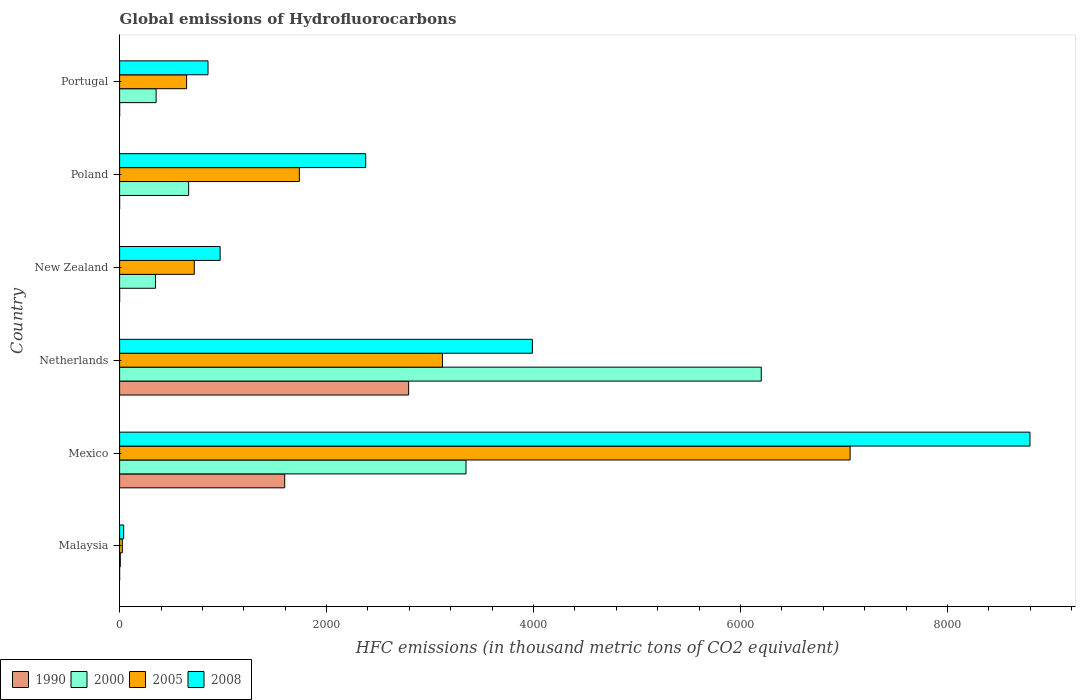How many different coloured bars are there?
Your response must be concise. 4. Are the number of bars on each tick of the Y-axis equal?
Your response must be concise. Yes. How many bars are there on the 6th tick from the top?
Ensure brevity in your answer.  4. How many bars are there on the 1st tick from the bottom?
Keep it short and to the point. 4. What is the label of the 5th group of bars from the top?
Offer a terse response. Mexico. In how many cases, is the number of bars for a given country not equal to the number of legend labels?
Offer a terse response. 0. What is the global emissions of Hydrofluorocarbons in 1990 in Mexico?
Make the answer very short. 1595.3. Across all countries, what is the maximum global emissions of Hydrofluorocarbons in 1990?
Keep it short and to the point. 2792.9. Across all countries, what is the minimum global emissions of Hydrofluorocarbons in 2005?
Provide a succinct answer. 26.1. In which country was the global emissions of Hydrofluorocarbons in 2008 maximum?
Provide a short and direct response. Mexico. In which country was the global emissions of Hydrofluorocarbons in 2005 minimum?
Provide a short and direct response. Malaysia. What is the total global emissions of Hydrofluorocarbons in 2005 in the graph?
Keep it short and to the point. 1.33e+04. What is the difference between the global emissions of Hydrofluorocarbons in 2005 in Malaysia and that in Portugal?
Ensure brevity in your answer.  -621.6. What is the difference between the global emissions of Hydrofluorocarbons in 2000 in Poland and the global emissions of Hydrofluorocarbons in 1990 in Mexico?
Your response must be concise. -928.1. What is the average global emissions of Hydrofluorocarbons in 1990 per country?
Keep it short and to the point. 731.47. What is the difference between the global emissions of Hydrofluorocarbons in 2000 and global emissions of Hydrofluorocarbons in 1990 in Malaysia?
Offer a very short reply. 6.8. What is the ratio of the global emissions of Hydrofluorocarbons in 1990 in Netherlands to that in Portugal?
Keep it short and to the point. 1.40e+04. Is the difference between the global emissions of Hydrofluorocarbons in 2000 in Malaysia and Mexico greater than the difference between the global emissions of Hydrofluorocarbons in 1990 in Malaysia and Mexico?
Make the answer very short. No. What is the difference between the highest and the second highest global emissions of Hydrofluorocarbons in 2000?
Your response must be concise. 2853.1. What is the difference between the highest and the lowest global emissions of Hydrofluorocarbons in 2008?
Make the answer very short. 8757.7. Is it the case that in every country, the sum of the global emissions of Hydrofluorocarbons in 2008 and global emissions of Hydrofluorocarbons in 2005 is greater than the sum of global emissions of Hydrofluorocarbons in 2000 and global emissions of Hydrofluorocarbons in 1990?
Offer a terse response. No. What does the 4th bar from the top in Netherlands represents?
Offer a terse response. 1990. Is it the case that in every country, the sum of the global emissions of Hydrofluorocarbons in 2008 and global emissions of Hydrofluorocarbons in 2000 is greater than the global emissions of Hydrofluorocarbons in 2005?
Give a very brief answer. Yes. Are the values on the major ticks of X-axis written in scientific E-notation?
Ensure brevity in your answer.  No. Does the graph contain any zero values?
Give a very brief answer. No. Does the graph contain grids?
Offer a very short reply. No. Where does the legend appear in the graph?
Give a very brief answer. Bottom left. How many legend labels are there?
Keep it short and to the point. 4. How are the legend labels stacked?
Provide a short and direct response. Horizontal. What is the title of the graph?
Provide a short and direct response. Global emissions of Hydrofluorocarbons. What is the label or title of the X-axis?
Make the answer very short. HFC emissions (in thousand metric tons of CO2 equivalent). What is the HFC emissions (in thousand metric tons of CO2 equivalent) of 1990 in Malaysia?
Your answer should be very brief. 0.1. What is the HFC emissions (in thousand metric tons of CO2 equivalent) in 2000 in Malaysia?
Make the answer very short. 6.9. What is the HFC emissions (in thousand metric tons of CO2 equivalent) in 2005 in Malaysia?
Your response must be concise. 26.1. What is the HFC emissions (in thousand metric tons of CO2 equivalent) of 2008 in Malaysia?
Your response must be concise. 39.2. What is the HFC emissions (in thousand metric tons of CO2 equivalent) in 1990 in Mexico?
Make the answer very short. 1595.3. What is the HFC emissions (in thousand metric tons of CO2 equivalent) of 2000 in Mexico?
Keep it short and to the point. 3347.3. What is the HFC emissions (in thousand metric tons of CO2 equivalent) in 2005 in Mexico?
Provide a short and direct response. 7058.9. What is the HFC emissions (in thousand metric tons of CO2 equivalent) in 2008 in Mexico?
Give a very brief answer. 8796.9. What is the HFC emissions (in thousand metric tons of CO2 equivalent) of 1990 in Netherlands?
Your answer should be compact. 2792.9. What is the HFC emissions (in thousand metric tons of CO2 equivalent) of 2000 in Netherlands?
Your answer should be very brief. 6200.4. What is the HFC emissions (in thousand metric tons of CO2 equivalent) of 2005 in Netherlands?
Your answer should be very brief. 3119.5. What is the HFC emissions (in thousand metric tons of CO2 equivalent) in 2008 in Netherlands?
Provide a short and direct response. 3988.8. What is the HFC emissions (in thousand metric tons of CO2 equivalent) in 1990 in New Zealand?
Make the answer very short. 0.2. What is the HFC emissions (in thousand metric tons of CO2 equivalent) in 2000 in New Zealand?
Ensure brevity in your answer.  347.3. What is the HFC emissions (in thousand metric tons of CO2 equivalent) in 2005 in New Zealand?
Make the answer very short. 721.7. What is the HFC emissions (in thousand metric tons of CO2 equivalent) of 2008 in New Zealand?
Keep it short and to the point. 971.4. What is the HFC emissions (in thousand metric tons of CO2 equivalent) of 2000 in Poland?
Provide a short and direct response. 667.2. What is the HFC emissions (in thousand metric tons of CO2 equivalent) in 2005 in Poland?
Give a very brief answer. 1736.7. What is the HFC emissions (in thousand metric tons of CO2 equivalent) of 2008 in Poland?
Your response must be concise. 2378. What is the HFC emissions (in thousand metric tons of CO2 equivalent) in 2000 in Portugal?
Provide a succinct answer. 352.7. What is the HFC emissions (in thousand metric tons of CO2 equivalent) in 2005 in Portugal?
Your answer should be compact. 647.7. What is the HFC emissions (in thousand metric tons of CO2 equivalent) of 2008 in Portugal?
Offer a terse response. 854.4. Across all countries, what is the maximum HFC emissions (in thousand metric tons of CO2 equivalent) in 1990?
Give a very brief answer. 2792.9. Across all countries, what is the maximum HFC emissions (in thousand metric tons of CO2 equivalent) of 2000?
Offer a terse response. 6200.4. Across all countries, what is the maximum HFC emissions (in thousand metric tons of CO2 equivalent) in 2005?
Offer a very short reply. 7058.9. Across all countries, what is the maximum HFC emissions (in thousand metric tons of CO2 equivalent) of 2008?
Give a very brief answer. 8796.9. Across all countries, what is the minimum HFC emissions (in thousand metric tons of CO2 equivalent) in 1990?
Offer a very short reply. 0.1. Across all countries, what is the minimum HFC emissions (in thousand metric tons of CO2 equivalent) of 2005?
Keep it short and to the point. 26.1. Across all countries, what is the minimum HFC emissions (in thousand metric tons of CO2 equivalent) in 2008?
Provide a succinct answer. 39.2. What is the total HFC emissions (in thousand metric tons of CO2 equivalent) in 1990 in the graph?
Offer a terse response. 4388.8. What is the total HFC emissions (in thousand metric tons of CO2 equivalent) in 2000 in the graph?
Ensure brevity in your answer.  1.09e+04. What is the total HFC emissions (in thousand metric tons of CO2 equivalent) in 2005 in the graph?
Offer a very short reply. 1.33e+04. What is the total HFC emissions (in thousand metric tons of CO2 equivalent) of 2008 in the graph?
Offer a very short reply. 1.70e+04. What is the difference between the HFC emissions (in thousand metric tons of CO2 equivalent) of 1990 in Malaysia and that in Mexico?
Your answer should be very brief. -1595.2. What is the difference between the HFC emissions (in thousand metric tons of CO2 equivalent) in 2000 in Malaysia and that in Mexico?
Ensure brevity in your answer.  -3340.4. What is the difference between the HFC emissions (in thousand metric tons of CO2 equivalent) of 2005 in Malaysia and that in Mexico?
Give a very brief answer. -7032.8. What is the difference between the HFC emissions (in thousand metric tons of CO2 equivalent) in 2008 in Malaysia and that in Mexico?
Provide a succinct answer. -8757.7. What is the difference between the HFC emissions (in thousand metric tons of CO2 equivalent) in 1990 in Malaysia and that in Netherlands?
Provide a short and direct response. -2792.8. What is the difference between the HFC emissions (in thousand metric tons of CO2 equivalent) of 2000 in Malaysia and that in Netherlands?
Your response must be concise. -6193.5. What is the difference between the HFC emissions (in thousand metric tons of CO2 equivalent) in 2005 in Malaysia and that in Netherlands?
Offer a terse response. -3093.4. What is the difference between the HFC emissions (in thousand metric tons of CO2 equivalent) in 2008 in Malaysia and that in Netherlands?
Give a very brief answer. -3949.6. What is the difference between the HFC emissions (in thousand metric tons of CO2 equivalent) of 2000 in Malaysia and that in New Zealand?
Ensure brevity in your answer.  -340.4. What is the difference between the HFC emissions (in thousand metric tons of CO2 equivalent) of 2005 in Malaysia and that in New Zealand?
Offer a terse response. -695.6. What is the difference between the HFC emissions (in thousand metric tons of CO2 equivalent) of 2008 in Malaysia and that in New Zealand?
Offer a terse response. -932.2. What is the difference between the HFC emissions (in thousand metric tons of CO2 equivalent) of 1990 in Malaysia and that in Poland?
Provide a succinct answer. 0. What is the difference between the HFC emissions (in thousand metric tons of CO2 equivalent) of 2000 in Malaysia and that in Poland?
Your answer should be compact. -660.3. What is the difference between the HFC emissions (in thousand metric tons of CO2 equivalent) in 2005 in Malaysia and that in Poland?
Make the answer very short. -1710.6. What is the difference between the HFC emissions (in thousand metric tons of CO2 equivalent) of 2008 in Malaysia and that in Poland?
Provide a succinct answer. -2338.8. What is the difference between the HFC emissions (in thousand metric tons of CO2 equivalent) in 1990 in Malaysia and that in Portugal?
Offer a very short reply. -0.1. What is the difference between the HFC emissions (in thousand metric tons of CO2 equivalent) of 2000 in Malaysia and that in Portugal?
Your answer should be very brief. -345.8. What is the difference between the HFC emissions (in thousand metric tons of CO2 equivalent) in 2005 in Malaysia and that in Portugal?
Offer a very short reply. -621.6. What is the difference between the HFC emissions (in thousand metric tons of CO2 equivalent) in 2008 in Malaysia and that in Portugal?
Your answer should be compact. -815.2. What is the difference between the HFC emissions (in thousand metric tons of CO2 equivalent) of 1990 in Mexico and that in Netherlands?
Your response must be concise. -1197.6. What is the difference between the HFC emissions (in thousand metric tons of CO2 equivalent) of 2000 in Mexico and that in Netherlands?
Make the answer very short. -2853.1. What is the difference between the HFC emissions (in thousand metric tons of CO2 equivalent) of 2005 in Mexico and that in Netherlands?
Give a very brief answer. 3939.4. What is the difference between the HFC emissions (in thousand metric tons of CO2 equivalent) in 2008 in Mexico and that in Netherlands?
Your answer should be compact. 4808.1. What is the difference between the HFC emissions (in thousand metric tons of CO2 equivalent) in 1990 in Mexico and that in New Zealand?
Keep it short and to the point. 1595.1. What is the difference between the HFC emissions (in thousand metric tons of CO2 equivalent) of 2000 in Mexico and that in New Zealand?
Offer a very short reply. 3000. What is the difference between the HFC emissions (in thousand metric tons of CO2 equivalent) of 2005 in Mexico and that in New Zealand?
Your answer should be very brief. 6337.2. What is the difference between the HFC emissions (in thousand metric tons of CO2 equivalent) in 2008 in Mexico and that in New Zealand?
Provide a short and direct response. 7825.5. What is the difference between the HFC emissions (in thousand metric tons of CO2 equivalent) of 1990 in Mexico and that in Poland?
Your answer should be compact. 1595.2. What is the difference between the HFC emissions (in thousand metric tons of CO2 equivalent) in 2000 in Mexico and that in Poland?
Your answer should be very brief. 2680.1. What is the difference between the HFC emissions (in thousand metric tons of CO2 equivalent) of 2005 in Mexico and that in Poland?
Make the answer very short. 5322.2. What is the difference between the HFC emissions (in thousand metric tons of CO2 equivalent) in 2008 in Mexico and that in Poland?
Provide a succinct answer. 6418.9. What is the difference between the HFC emissions (in thousand metric tons of CO2 equivalent) of 1990 in Mexico and that in Portugal?
Provide a succinct answer. 1595.1. What is the difference between the HFC emissions (in thousand metric tons of CO2 equivalent) in 2000 in Mexico and that in Portugal?
Give a very brief answer. 2994.6. What is the difference between the HFC emissions (in thousand metric tons of CO2 equivalent) of 2005 in Mexico and that in Portugal?
Give a very brief answer. 6411.2. What is the difference between the HFC emissions (in thousand metric tons of CO2 equivalent) of 2008 in Mexico and that in Portugal?
Offer a very short reply. 7942.5. What is the difference between the HFC emissions (in thousand metric tons of CO2 equivalent) in 1990 in Netherlands and that in New Zealand?
Your answer should be compact. 2792.7. What is the difference between the HFC emissions (in thousand metric tons of CO2 equivalent) of 2000 in Netherlands and that in New Zealand?
Your answer should be very brief. 5853.1. What is the difference between the HFC emissions (in thousand metric tons of CO2 equivalent) in 2005 in Netherlands and that in New Zealand?
Ensure brevity in your answer.  2397.8. What is the difference between the HFC emissions (in thousand metric tons of CO2 equivalent) of 2008 in Netherlands and that in New Zealand?
Keep it short and to the point. 3017.4. What is the difference between the HFC emissions (in thousand metric tons of CO2 equivalent) in 1990 in Netherlands and that in Poland?
Keep it short and to the point. 2792.8. What is the difference between the HFC emissions (in thousand metric tons of CO2 equivalent) of 2000 in Netherlands and that in Poland?
Provide a succinct answer. 5533.2. What is the difference between the HFC emissions (in thousand metric tons of CO2 equivalent) in 2005 in Netherlands and that in Poland?
Your response must be concise. 1382.8. What is the difference between the HFC emissions (in thousand metric tons of CO2 equivalent) of 2008 in Netherlands and that in Poland?
Provide a succinct answer. 1610.8. What is the difference between the HFC emissions (in thousand metric tons of CO2 equivalent) in 1990 in Netherlands and that in Portugal?
Your response must be concise. 2792.7. What is the difference between the HFC emissions (in thousand metric tons of CO2 equivalent) of 2000 in Netherlands and that in Portugal?
Provide a succinct answer. 5847.7. What is the difference between the HFC emissions (in thousand metric tons of CO2 equivalent) in 2005 in Netherlands and that in Portugal?
Ensure brevity in your answer.  2471.8. What is the difference between the HFC emissions (in thousand metric tons of CO2 equivalent) in 2008 in Netherlands and that in Portugal?
Keep it short and to the point. 3134.4. What is the difference between the HFC emissions (in thousand metric tons of CO2 equivalent) of 2000 in New Zealand and that in Poland?
Provide a short and direct response. -319.9. What is the difference between the HFC emissions (in thousand metric tons of CO2 equivalent) of 2005 in New Zealand and that in Poland?
Make the answer very short. -1015. What is the difference between the HFC emissions (in thousand metric tons of CO2 equivalent) in 2008 in New Zealand and that in Poland?
Provide a succinct answer. -1406.6. What is the difference between the HFC emissions (in thousand metric tons of CO2 equivalent) in 2000 in New Zealand and that in Portugal?
Make the answer very short. -5.4. What is the difference between the HFC emissions (in thousand metric tons of CO2 equivalent) in 2005 in New Zealand and that in Portugal?
Offer a terse response. 74. What is the difference between the HFC emissions (in thousand metric tons of CO2 equivalent) in 2008 in New Zealand and that in Portugal?
Ensure brevity in your answer.  117. What is the difference between the HFC emissions (in thousand metric tons of CO2 equivalent) of 2000 in Poland and that in Portugal?
Keep it short and to the point. 314.5. What is the difference between the HFC emissions (in thousand metric tons of CO2 equivalent) of 2005 in Poland and that in Portugal?
Ensure brevity in your answer.  1089. What is the difference between the HFC emissions (in thousand metric tons of CO2 equivalent) in 2008 in Poland and that in Portugal?
Your answer should be compact. 1523.6. What is the difference between the HFC emissions (in thousand metric tons of CO2 equivalent) of 1990 in Malaysia and the HFC emissions (in thousand metric tons of CO2 equivalent) of 2000 in Mexico?
Provide a short and direct response. -3347.2. What is the difference between the HFC emissions (in thousand metric tons of CO2 equivalent) of 1990 in Malaysia and the HFC emissions (in thousand metric tons of CO2 equivalent) of 2005 in Mexico?
Offer a terse response. -7058.8. What is the difference between the HFC emissions (in thousand metric tons of CO2 equivalent) of 1990 in Malaysia and the HFC emissions (in thousand metric tons of CO2 equivalent) of 2008 in Mexico?
Keep it short and to the point. -8796.8. What is the difference between the HFC emissions (in thousand metric tons of CO2 equivalent) of 2000 in Malaysia and the HFC emissions (in thousand metric tons of CO2 equivalent) of 2005 in Mexico?
Offer a very short reply. -7052. What is the difference between the HFC emissions (in thousand metric tons of CO2 equivalent) in 2000 in Malaysia and the HFC emissions (in thousand metric tons of CO2 equivalent) in 2008 in Mexico?
Your response must be concise. -8790. What is the difference between the HFC emissions (in thousand metric tons of CO2 equivalent) in 2005 in Malaysia and the HFC emissions (in thousand metric tons of CO2 equivalent) in 2008 in Mexico?
Offer a very short reply. -8770.8. What is the difference between the HFC emissions (in thousand metric tons of CO2 equivalent) of 1990 in Malaysia and the HFC emissions (in thousand metric tons of CO2 equivalent) of 2000 in Netherlands?
Provide a succinct answer. -6200.3. What is the difference between the HFC emissions (in thousand metric tons of CO2 equivalent) of 1990 in Malaysia and the HFC emissions (in thousand metric tons of CO2 equivalent) of 2005 in Netherlands?
Your response must be concise. -3119.4. What is the difference between the HFC emissions (in thousand metric tons of CO2 equivalent) in 1990 in Malaysia and the HFC emissions (in thousand metric tons of CO2 equivalent) in 2008 in Netherlands?
Provide a succinct answer. -3988.7. What is the difference between the HFC emissions (in thousand metric tons of CO2 equivalent) of 2000 in Malaysia and the HFC emissions (in thousand metric tons of CO2 equivalent) of 2005 in Netherlands?
Offer a terse response. -3112.6. What is the difference between the HFC emissions (in thousand metric tons of CO2 equivalent) in 2000 in Malaysia and the HFC emissions (in thousand metric tons of CO2 equivalent) in 2008 in Netherlands?
Give a very brief answer. -3981.9. What is the difference between the HFC emissions (in thousand metric tons of CO2 equivalent) of 2005 in Malaysia and the HFC emissions (in thousand metric tons of CO2 equivalent) of 2008 in Netherlands?
Offer a terse response. -3962.7. What is the difference between the HFC emissions (in thousand metric tons of CO2 equivalent) of 1990 in Malaysia and the HFC emissions (in thousand metric tons of CO2 equivalent) of 2000 in New Zealand?
Offer a very short reply. -347.2. What is the difference between the HFC emissions (in thousand metric tons of CO2 equivalent) of 1990 in Malaysia and the HFC emissions (in thousand metric tons of CO2 equivalent) of 2005 in New Zealand?
Provide a succinct answer. -721.6. What is the difference between the HFC emissions (in thousand metric tons of CO2 equivalent) in 1990 in Malaysia and the HFC emissions (in thousand metric tons of CO2 equivalent) in 2008 in New Zealand?
Provide a succinct answer. -971.3. What is the difference between the HFC emissions (in thousand metric tons of CO2 equivalent) of 2000 in Malaysia and the HFC emissions (in thousand metric tons of CO2 equivalent) of 2005 in New Zealand?
Your answer should be very brief. -714.8. What is the difference between the HFC emissions (in thousand metric tons of CO2 equivalent) of 2000 in Malaysia and the HFC emissions (in thousand metric tons of CO2 equivalent) of 2008 in New Zealand?
Provide a short and direct response. -964.5. What is the difference between the HFC emissions (in thousand metric tons of CO2 equivalent) of 2005 in Malaysia and the HFC emissions (in thousand metric tons of CO2 equivalent) of 2008 in New Zealand?
Make the answer very short. -945.3. What is the difference between the HFC emissions (in thousand metric tons of CO2 equivalent) of 1990 in Malaysia and the HFC emissions (in thousand metric tons of CO2 equivalent) of 2000 in Poland?
Ensure brevity in your answer.  -667.1. What is the difference between the HFC emissions (in thousand metric tons of CO2 equivalent) in 1990 in Malaysia and the HFC emissions (in thousand metric tons of CO2 equivalent) in 2005 in Poland?
Provide a short and direct response. -1736.6. What is the difference between the HFC emissions (in thousand metric tons of CO2 equivalent) of 1990 in Malaysia and the HFC emissions (in thousand metric tons of CO2 equivalent) of 2008 in Poland?
Provide a succinct answer. -2377.9. What is the difference between the HFC emissions (in thousand metric tons of CO2 equivalent) of 2000 in Malaysia and the HFC emissions (in thousand metric tons of CO2 equivalent) of 2005 in Poland?
Your answer should be very brief. -1729.8. What is the difference between the HFC emissions (in thousand metric tons of CO2 equivalent) in 2000 in Malaysia and the HFC emissions (in thousand metric tons of CO2 equivalent) in 2008 in Poland?
Give a very brief answer. -2371.1. What is the difference between the HFC emissions (in thousand metric tons of CO2 equivalent) of 2005 in Malaysia and the HFC emissions (in thousand metric tons of CO2 equivalent) of 2008 in Poland?
Offer a very short reply. -2351.9. What is the difference between the HFC emissions (in thousand metric tons of CO2 equivalent) in 1990 in Malaysia and the HFC emissions (in thousand metric tons of CO2 equivalent) in 2000 in Portugal?
Provide a succinct answer. -352.6. What is the difference between the HFC emissions (in thousand metric tons of CO2 equivalent) of 1990 in Malaysia and the HFC emissions (in thousand metric tons of CO2 equivalent) of 2005 in Portugal?
Offer a terse response. -647.6. What is the difference between the HFC emissions (in thousand metric tons of CO2 equivalent) in 1990 in Malaysia and the HFC emissions (in thousand metric tons of CO2 equivalent) in 2008 in Portugal?
Your answer should be compact. -854.3. What is the difference between the HFC emissions (in thousand metric tons of CO2 equivalent) in 2000 in Malaysia and the HFC emissions (in thousand metric tons of CO2 equivalent) in 2005 in Portugal?
Give a very brief answer. -640.8. What is the difference between the HFC emissions (in thousand metric tons of CO2 equivalent) in 2000 in Malaysia and the HFC emissions (in thousand metric tons of CO2 equivalent) in 2008 in Portugal?
Make the answer very short. -847.5. What is the difference between the HFC emissions (in thousand metric tons of CO2 equivalent) of 2005 in Malaysia and the HFC emissions (in thousand metric tons of CO2 equivalent) of 2008 in Portugal?
Your response must be concise. -828.3. What is the difference between the HFC emissions (in thousand metric tons of CO2 equivalent) in 1990 in Mexico and the HFC emissions (in thousand metric tons of CO2 equivalent) in 2000 in Netherlands?
Keep it short and to the point. -4605.1. What is the difference between the HFC emissions (in thousand metric tons of CO2 equivalent) of 1990 in Mexico and the HFC emissions (in thousand metric tons of CO2 equivalent) of 2005 in Netherlands?
Give a very brief answer. -1524.2. What is the difference between the HFC emissions (in thousand metric tons of CO2 equivalent) in 1990 in Mexico and the HFC emissions (in thousand metric tons of CO2 equivalent) in 2008 in Netherlands?
Ensure brevity in your answer.  -2393.5. What is the difference between the HFC emissions (in thousand metric tons of CO2 equivalent) in 2000 in Mexico and the HFC emissions (in thousand metric tons of CO2 equivalent) in 2005 in Netherlands?
Keep it short and to the point. 227.8. What is the difference between the HFC emissions (in thousand metric tons of CO2 equivalent) in 2000 in Mexico and the HFC emissions (in thousand metric tons of CO2 equivalent) in 2008 in Netherlands?
Provide a succinct answer. -641.5. What is the difference between the HFC emissions (in thousand metric tons of CO2 equivalent) in 2005 in Mexico and the HFC emissions (in thousand metric tons of CO2 equivalent) in 2008 in Netherlands?
Provide a succinct answer. 3070.1. What is the difference between the HFC emissions (in thousand metric tons of CO2 equivalent) in 1990 in Mexico and the HFC emissions (in thousand metric tons of CO2 equivalent) in 2000 in New Zealand?
Your answer should be very brief. 1248. What is the difference between the HFC emissions (in thousand metric tons of CO2 equivalent) in 1990 in Mexico and the HFC emissions (in thousand metric tons of CO2 equivalent) in 2005 in New Zealand?
Ensure brevity in your answer.  873.6. What is the difference between the HFC emissions (in thousand metric tons of CO2 equivalent) in 1990 in Mexico and the HFC emissions (in thousand metric tons of CO2 equivalent) in 2008 in New Zealand?
Offer a very short reply. 623.9. What is the difference between the HFC emissions (in thousand metric tons of CO2 equivalent) in 2000 in Mexico and the HFC emissions (in thousand metric tons of CO2 equivalent) in 2005 in New Zealand?
Offer a very short reply. 2625.6. What is the difference between the HFC emissions (in thousand metric tons of CO2 equivalent) of 2000 in Mexico and the HFC emissions (in thousand metric tons of CO2 equivalent) of 2008 in New Zealand?
Your response must be concise. 2375.9. What is the difference between the HFC emissions (in thousand metric tons of CO2 equivalent) of 2005 in Mexico and the HFC emissions (in thousand metric tons of CO2 equivalent) of 2008 in New Zealand?
Your answer should be very brief. 6087.5. What is the difference between the HFC emissions (in thousand metric tons of CO2 equivalent) of 1990 in Mexico and the HFC emissions (in thousand metric tons of CO2 equivalent) of 2000 in Poland?
Ensure brevity in your answer.  928.1. What is the difference between the HFC emissions (in thousand metric tons of CO2 equivalent) of 1990 in Mexico and the HFC emissions (in thousand metric tons of CO2 equivalent) of 2005 in Poland?
Your answer should be compact. -141.4. What is the difference between the HFC emissions (in thousand metric tons of CO2 equivalent) in 1990 in Mexico and the HFC emissions (in thousand metric tons of CO2 equivalent) in 2008 in Poland?
Your response must be concise. -782.7. What is the difference between the HFC emissions (in thousand metric tons of CO2 equivalent) of 2000 in Mexico and the HFC emissions (in thousand metric tons of CO2 equivalent) of 2005 in Poland?
Offer a terse response. 1610.6. What is the difference between the HFC emissions (in thousand metric tons of CO2 equivalent) of 2000 in Mexico and the HFC emissions (in thousand metric tons of CO2 equivalent) of 2008 in Poland?
Make the answer very short. 969.3. What is the difference between the HFC emissions (in thousand metric tons of CO2 equivalent) in 2005 in Mexico and the HFC emissions (in thousand metric tons of CO2 equivalent) in 2008 in Poland?
Your answer should be compact. 4680.9. What is the difference between the HFC emissions (in thousand metric tons of CO2 equivalent) in 1990 in Mexico and the HFC emissions (in thousand metric tons of CO2 equivalent) in 2000 in Portugal?
Your answer should be very brief. 1242.6. What is the difference between the HFC emissions (in thousand metric tons of CO2 equivalent) in 1990 in Mexico and the HFC emissions (in thousand metric tons of CO2 equivalent) in 2005 in Portugal?
Provide a short and direct response. 947.6. What is the difference between the HFC emissions (in thousand metric tons of CO2 equivalent) of 1990 in Mexico and the HFC emissions (in thousand metric tons of CO2 equivalent) of 2008 in Portugal?
Make the answer very short. 740.9. What is the difference between the HFC emissions (in thousand metric tons of CO2 equivalent) in 2000 in Mexico and the HFC emissions (in thousand metric tons of CO2 equivalent) in 2005 in Portugal?
Provide a short and direct response. 2699.6. What is the difference between the HFC emissions (in thousand metric tons of CO2 equivalent) of 2000 in Mexico and the HFC emissions (in thousand metric tons of CO2 equivalent) of 2008 in Portugal?
Ensure brevity in your answer.  2492.9. What is the difference between the HFC emissions (in thousand metric tons of CO2 equivalent) of 2005 in Mexico and the HFC emissions (in thousand metric tons of CO2 equivalent) of 2008 in Portugal?
Offer a terse response. 6204.5. What is the difference between the HFC emissions (in thousand metric tons of CO2 equivalent) in 1990 in Netherlands and the HFC emissions (in thousand metric tons of CO2 equivalent) in 2000 in New Zealand?
Your response must be concise. 2445.6. What is the difference between the HFC emissions (in thousand metric tons of CO2 equivalent) in 1990 in Netherlands and the HFC emissions (in thousand metric tons of CO2 equivalent) in 2005 in New Zealand?
Your answer should be very brief. 2071.2. What is the difference between the HFC emissions (in thousand metric tons of CO2 equivalent) in 1990 in Netherlands and the HFC emissions (in thousand metric tons of CO2 equivalent) in 2008 in New Zealand?
Your response must be concise. 1821.5. What is the difference between the HFC emissions (in thousand metric tons of CO2 equivalent) of 2000 in Netherlands and the HFC emissions (in thousand metric tons of CO2 equivalent) of 2005 in New Zealand?
Your answer should be very brief. 5478.7. What is the difference between the HFC emissions (in thousand metric tons of CO2 equivalent) in 2000 in Netherlands and the HFC emissions (in thousand metric tons of CO2 equivalent) in 2008 in New Zealand?
Offer a terse response. 5229. What is the difference between the HFC emissions (in thousand metric tons of CO2 equivalent) of 2005 in Netherlands and the HFC emissions (in thousand metric tons of CO2 equivalent) of 2008 in New Zealand?
Your answer should be compact. 2148.1. What is the difference between the HFC emissions (in thousand metric tons of CO2 equivalent) in 1990 in Netherlands and the HFC emissions (in thousand metric tons of CO2 equivalent) in 2000 in Poland?
Keep it short and to the point. 2125.7. What is the difference between the HFC emissions (in thousand metric tons of CO2 equivalent) in 1990 in Netherlands and the HFC emissions (in thousand metric tons of CO2 equivalent) in 2005 in Poland?
Give a very brief answer. 1056.2. What is the difference between the HFC emissions (in thousand metric tons of CO2 equivalent) in 1990 in Netherlands and the HFC emissions (in thousand metric tons of CO2 equivalent) in 2008 in Poland?
Your answer should be very brief. 414.9. What is the difference between the HFC emissions (in thousand metric tons of CO2 equivalent) of 2000 in Netherlands and the HFC emissions (in thousand metric tons of CO2 equivalent) of 2005 in Poland?
Keep it short and to the point. 4463.7. What is the difference between the HFC emissions (in thousand metric tons of CO2 equivalent) in 2000 in Netherlands and the HFC emissions (in thousand metric tons of CO2 equivalent) in 2008 in Poland?
Offer a very short reply. 3822.4. What is the difference between the HFC emissions (in thousand metric tons of CO2 equivalent) of 2005 in Netherlands and the HFC emissions (in thousand metric tons of CO2 equivalent) of 2008 in Poland?
Offer a terse response. 741.5. What is the difference between the HFC emissions (in thousand metric tons of CO2 equivalent) in 1990 in Netherlands and the HFC emissions (in thousand metric tons of CO2 equivalent) in 2000 in Portugal?
Offer a very short reply. 2440.2. What is the difference between the HFC emissions (in thousand metric tons of CO2 equivalent) in 1990 in Netherlands and the HFC emissions (in thousand metric tons of CO2 equivalent) in 2005 in Portugal?
Your answer should be very brief. 2145.2. What is the difference between the HFC emissions (in thousand metric tons of CO2 equivalent) of 1990 in Netherlands and the HFC emissions (in thousand metric tons of CO2 equivalent) of 2008 in Portugal?
Provide a short and direct response. 1938.5. What is the difference between the HFC emissions (in thousand metric tons of CO2 equivalent) of 2000 in Netherlands and the HFC emissions (in thousand metric tons of CO2 equivalent) of 2005 in Portugal?
Keep it short and to the point. 5552.7. What is the difference between the HFC emissions (in thousand metric tons of CO2 equivalent) of 2000 in Netherlands and the HFC emissions (in thousand metric tons of CO2 equivalent) of 2008 in Portugal?
Offer a very short reply. 5346. What is the difference between the HFC emissions (in thousand metric tons of CO2 equivalent) of 2005 in Netherlands and the HFC emissions (in thousand metric tons of CO2 equivalent) of 2008 in Portugal?
Offer a terse response. 2265.1. What is the difference between the HFC emissions (in thousand metric tons of CO2 equivalent) in 1990 in New Zealand and the HFC emissions (in thousand metric tons of CO2 equivalent) in 2000 in Poland?
Your answer should be very brief. -667. What is the difference between the HFC emissions (in thousand metric tons of CO2 equivalent) of 1990 in New Zealand and the HFC emissions (in thousand metric tons of CO2 equivalent) of 2005 in Poland?
Give a very brief answer. -1736.5. What is the difference between the HFC emissions (in thousand metric tons of CO2 equivalent) of 1990 in New Zealand and the HFC emissions (in thousand metric tons of CO2 equivalent) of 2008 in Poland?
Provide a succinct answer. -2377.8. What is the difference between the HFC emissions (in thousand metric tons of CO2 equivalent) of 2000 in New Zealand and the HFC emissions (in thousand metric tons of CO2 equivalent) of 2005 in Poland?
Keep it short and to the point. -1389.4. What is the difference between the HFC emissions (in thousand metric tons of CO2 equivalent) of 2000 in New Zealand and the HFC emissions (in thousand metric tons of CO2 equivalent) of 2008 in Poland?
Ensure brevity in your answer.  -2030.7. What is the difference between the HFC emissions (in thousand metric tons of CO2 equivalent) in 2005 in New Zealand and the HFC emissions (in thousand metric tons of CO2 equivalent) in 2008 in Poland?
Offer a very short reply. -1656.3. What is the difference between the HFC emissions (in thousand metric tons of CO2 equivalent) of 1990 in New Zealand and the HFC emissions (in thousand metric tons of CO2 equivalent) of 2000 in Portugal?
Your answer should be very brief. -352.5. What is the difference between the HFC emissions (in thousand metric tons of CO2 equivalent) of 1990 in New Zealand and the HFC emissions (in thousand metric tons of CO2 equivalent) of 2005 in Portugal?
Offer a very short reply. -647.5. What is the difference between the HFC emissions (in thousand metric tons of CO2 equivalent) in 1990 in New Zealand and the HFC emissions (in thousand metric tons of CO2 equivalent) in 2008 in Portugal?
Keep it short and to the point. -854.2. What is the difference between the HFC emissions (in thousand metric tons of CO2 equivalent) in 2000 in New Zealand and the HFC emissions (in thousand metric tons of CO2 equivalent) in 2005 in Portugal?
Give a very brief answer. -300.4. What is the difference between the HFC emissions (in thousand metric tons of CO2 equivalent) in 2000 in New Zealand and the HFC emissions (in thousand metric tons of CO2 equivalent) in 2008 in Portugal?
Ensure brevity in your answer.  -507.1. What is the difference between the HFC emissions (in thousand metric tons of CO2 equivalent) in 2005 in New Zealand and the HFC emissions (in thousand metric tons of CO2 equivalent) in 2008 in Portugal?
Provide a succinct answer. -132.7. What is the difference between the HFC emissions (in thousand metric tons of CO2 equivalent) of 1990 in Poland and the HFC emissions (in thousand metric tons of CO2 equivalent) of 2000 in Portugal?
Your answer should be very brief. -352.6. What is the difference between the HFC emissions (in thousand metric tons of CO2 equivalent) in 1990 in Poland and the HFC emissions (in thousand metric tons of CO2 equivalent) in 2005 in Portugal?
Ensure brevity in your answer.  -647.6. What is the difference between the HFC emissions (in thousand metric tons of CO2 equivalent) of 1990 in Poland and the HFC emissions (in thousand metric tons of CO2 equivalent) of 2008 in Portugal?
Give a very brief answer. -854.3. What is the difference between the HFC emissions (in thousand metric tons of CO2 equivalent) in 2000 in Poland and the HFC emissions (in thousand metric tons of CO2 equivalent) in 2008 in Portugal?
Give a very brief answer. -187.2. What is the difference between the HFC emissions (in thousand metric tons of CO2 equivalent) of 2005 in Poland and the HFC emissions (in thousand metric tons of CO2 equivalent) of 2008 in Portugal?
Make the answer very short. 882.3. What is the average HFC emissions (in thousand metric tons of CO2 equivalent) in 1990 per country?
Provide a short and direct response. 731.47. What is the average HFC emissions (in thousand metric tons of CO2 equivalent) of 2000 per country?
Provide a succinct answer. 1820.3. What is the average HFC emissions (in thousand metric tons of CO2 equivalent) of 2005 per country?
Provide a short and direct response. 2218.43. What is the average HFC emissions (in thousand metric tons of CO2 equivalent) of 2008 per country?
Your answer should be compact. 2838.12. What is the difference between the HFC emissions (in thousand metric tons of CO2 equivalent) in 1990 and HFC emissions (in thousand metric tons of CO2 equivalent) in 2008 in Malaysia?
Ensure brevity in your answer.  -39.1. What is the difference between the HFC emissions (in thousand metric tons of CO2 equivalent) in 2000 and HFC emissions (in thousand metric tons of CO2 equivalent) in 2005 in Malaysia?
Offer a very short reply. -19.2. What is the difference between the HFC emissions (in thousand metric tons of CO2 equivalent) in 2000 and HFC emissions (in thousand metric tons of CO2 equivalent) in 2008 in Malaysia?
Provide a short and direct response. -32.3. What is the difference between the HFC emissions (in thousand metric tons of CO2 equivalent) in 1990 and HFC emissions (in thousand metric tons of CO2 equivalent) in 2000 in Mexico?
Provide a succinct answer. -1752. What is the difference between the HFC emissions (in thousand metric tons of CO2 equivalent) in 1990 and HFC emissions (in thousand metric tons of CO2 equivalent) in 2005 in Mexico?
Ensure brevity in your answer.  -5463.6. What is the difference between the HFC emissions (in thousand metric tons of CO2 equivalent) in 1990 and HFC emissions (in thousand metric tons of CO2 equivalent) in 2008 in Mexico?
Provide a short and direct response. -7201.6. What is the difference between the HFC emissions (in thousand metric tons of CO2 equivalent) of 2000 and HFC emissions (in thousand metric tons of CO2 equivalent) of 2005 in Mexico?
Give a very brief answer. -3711.6. What is the difference between the HFC emissions (in thousand metric tons of CO2 equivalent) in 2000 and HFC emissions (in thousand metric tons of CO2 equivalent) in 2008 in Mexico?
Your answer should be very brief. -5449.6. What is the difference between the HFC emissions (in thousand metric tons of CO2 equivalent) in 2005 and HFC emissions (in thousand metric tons of CO2 equivalent) in 2008 in Mexico?
Give a very brief answer. -1738. What is the difference between the HFC emissions (in thousand metric tons of CO2 equivalent) in 1990 and HFC emissions (in thousand metric tons of CO2 equivalent) in 2000 in Netherlands?
Offer a terse response. -3407.5. What is the difference between the HFC emissions (in thousand metric tons of CO2 equivalent) in 1990 and HFC emissions (in thousand metric tons of CO2 equivalent) in 2005 in Netherlands?
Your answer should be very brief. -326.6. What is the difference between the HFC emissions (in thousand metric tons of CO2 equivalent) of 1990 and HFC emissions (in thousand metric tons of CO2 equivalent) of 2008 in Netherlands?
Your answer should be compact. -1195.9. What is the difference between the HFC emissions (in thousand metric tons of CO2 equivalent) of 2000 and HFC emissions (in thousand metric tons of CO2 equivalent) of 2005 in Netherlands?
Offer a terse response. 3080.9. What is the difference between the HFC emissions (in thousand metric tons of CO2 equivalent) in 2000 and HFC emissions (in thousand metric tons of CO2 equivalent) in 2008 in Netherlands?
Ensure brevity in your answer.  2211.6. What is the difference between the HFC emissions (in thousand metric tons of CO2 equivalent) in 2005 and HFC emissions (in thousand metric tons of CO2 equivalent) in 2008 in Netherlands?
Provide a succinct answer. -869.3. What is the difference between the HFC emissions (in thousand metric tons of CO2 equivalent) of 1990 and HFC emissions (in thousand metric tons of CO2 equivalent) of 2000 in New Zealand?
Your response must be concise. -347.1. What is the difference between the HFC emissions (in thousand metric tons of CO2 equivalent) of 1990 and HFC emissions (in thousand metric tons of CO2 equivalent) of 2005 in New Zealand?
Provide a succinct answer. -721.5. What is the difference between the HFC emissions (in thousand metric tons of CO2 equivalent) in 1990 and HFC emissions (in thousand metric tons of CO2 equivalent) in 2008 in New Zealand?
Offer a terse response. -971.2. What is the difference between the HFC emissions (in thousand metric tons of CO2 equivalent) in 2000 and HFC emissions (in thousand metric tons of CO2 equivalent) in 2005 in New Zealand?
Make the answer very short. -374.4. What is the difference between the HFC emissions (in thousand metric tons of CO2 equivalent) in 2000 and HFC emissions (in thousand metric tons of CO2 equivalent) in 2008 in New Zealand?
Your answer should be compact. -624.1. What is the difference between the HFC emissions (in thousand metric tons of CO2 equivalent) of 2005 and HFC emissions (in thousand metric tons of CO2 equivalent) of 2008 in New Zealand?
Offer a very short reply. -249.7. What is the difference between the HFC emissions (in thousand metric tons of CO2 equivalent) of 1990 and HFC emissions (in thousand metric tons of CO2 equivalent) of 2000 in Poland?
Offer a terse response. -667.1. What is the difference between the HFC emissions (in thousand metric tons of CO2 equivalent) in 1990 and HFC emissions (in thousand metric tons of CO2 equivalent) in 2005 in Poland?
Provide a succinct answer. -1736.6. What is the difference between the HFC emissions (in thousand metric tons of CO2 equivalent) in 1990 and HFC emissions (in thousand metric tons of CO2 equivalent) in 2008 in Poland?
Your answer should be very brief. -2377.9. What is the difference between the HFC emissions (in thousand metric tons of CO2 equivalent) of 2000 and HFC emissions (in thousand metric tons of CO2 equivalent) of 2005 in Poland?
Your response must be concise. -1069.5. What is the difference between the HFC emissions (in thousand metric tons of CO2 equivalent) in 2000 and HFC emissions (in thousand metric tons of CO2 equivalent) in 2008 in Poland?
Keep it short and to the point. -1710.8. What is the difference between the HFC emissions (in thousand metric tons of CO2 equivalent) of 2005 and HFC emissions (in thousand metric tons of CO2 equivalent) of 2008 in Poland?
Keep it short and to the point. -641.3. What is the difference between the HFC emissions (in thousand metric tons of CO2 equivalent) in 1990 and HFC emissions (in thousand metric tons of CO2 equivalent) in 2000 in Portugal?
Offer a very short reply. -352.5. What is the difference between the HFC emissions (in thousand metric tons of CO2 equivalent) of 1990 and HFC emissions (in thousand metric tons of CO2 equivalent) of 2005 in Portugal?
Offer a very short reply. -647.5. What is the difference between the HFC emissions (in thousand metric tons of CO2 equivalent) of 1990 and HFC emissions (in thousand metric tons of CO2 equivalent) of 2008 in Portugal?
Give a very brief answer. -854.2. What is the difference between the HFC emissions (in thousand metric tons of CO2 equivalent) in 2000 and HFC emissions (in thousand metric tons of CO2 equivalent) in 2005 in Portugal?
Provide a short and direct response. -295. What is the difference between the HFC emissions (in thousand metric tons of CO2 equivalent) of 2000 and HFC emissions (in thousand metric tons of CO2 equivalent) of 2008 in Portugal?
Provide a succinct answer. -501.7. What is the difference between the HFC emissions (in thousand metric tons of CO2 equivalent) in 2005 and HFC emissions (in thousand metric tons of CO2 equivalent) in 2008 in Portugal?
Give a very brief answer. -206.7. What is the ratio of the HFC emissions (in thousand metric tons of CO2 equivalent) of 1990 in Malaysia to that in Mexico?
Provide a succinct answer. 0. What is the ratio of the HFC emissions (in thousand metric tons of CO2 equivalent) of 2000 in Malaysia to that in Mexico?
Offer a terse response. 0. What is the ratio of the HFC emissions (in thousand metric tons of CO2 equivalent) of 2005 in Malaysia to that in Mexico?
Ensure brevity in your answer.  0. What is the ratio of the HFC emissions (in thousand metric tons of CO2 equivalent) of 2008 in Malaysia to that in Mexico?
Provide a short and direct response. 0. What is the ratio of the HFC emissions (in thousand metric tons of CO2 equivalent) of 2000 in Malaysia to that in Netherlands?
Your response must be concise. 0. What is the ratio of the HFC emissions (in thousand metric tons of CO2 equivalent) in 2005 in Malaysia to that in Netherlands?
Offer a very short reply. 0.01. What is the ratio of the HFC emissions (in thousand metric tons of CO2 equivalent) in 2008 in Malaysia to that in Netherlands?
Give a very brief answer. 0.01. What is the ratio of the HFC emissions (in thousand metric tons of CO2 equivalent) in 2000 in Malaysia to that in New Zealand?
Provide a short and direct response. 0.02. What is the ratio of the HFC emissions (in thousand metric tons of CO2 equivalent) of 2005 in Malaysia to that in New Zealand?
Your response must be concise. 0.04. What is the ratio of the HFC emissions (in thousand metric tons of CO2 equivalent) of 2008 in Malaysia to that in New Zealand?
Offer a terse response. 0.04. What is the ratio of the HFC emissions (in thousand metric tons of CO2 equivalent) in 2000 in Malaysia to that in Poland?
Your answer should be very brief. 0.01. What is the ratio of the HFC emissions (in thousand metric tons of CO2 equivalent) of 2005 in Malaysia to that in Poland?
Provide a succinct answer. 0.01. What is the ratio of the HFC emissions (in thousand metric tons of CO2 equivalent) of 2008 in Malaysia to that in Poland?
Ensure brevity in your answer.  0.02. What is the ratio of the HFC emissions (in thousand metric tons of CO2 equivalent) of 1990 in Malaysia to that in Portugal?
Your answer should be compact. 0.5. What is the ratio of the HFC emissions (in thousand metric tons of CO2 equivalent) of 2000 in Malaysia to that in Portugal?
Offer a very short reply. 0.02. What is the ratio of the HFC emissions (in thousand metric tons of CO2 equivalent) in 2005 in Malaysia to that in Portugal?
Give a very brief answer. 0.04. What is the ratio of the HFC emissions (in thousand metric tons of CO2 equivalent) in 2008 in Malaysia to that in Portugal?
Your response must be concise. 0.05. What is the ratio of the HFC emissions (in thousand metric tons of CO2 equivalent) in 1990 in Mexico to that in Netherlands?
Ensure brevity in your answer.  0.57. What is the ratio of the HFC emissions (in thousand metric tons of CO2 equivalent) in 2000 in Mexico to that in Netherlands?
Ensure brevity in your answer.  0.54. What is the ratio of the HFC emissions (in thousand metric tons of CO2 equivalent) of 2005 in Mexico to that in Netherlands?
Provide a short and direct response. 2.26. What is the ratio of the HFC emissions (in thousand metric tons of CO2 equivalent) of 2008 in Mexico to that in Netherlands?
Your answer should be compact. 2.21. What is the ratio of the HFC emissions (in thousand metric tons of CO2 equivalent) of 1990 in Mexico to that in New Zealand?
Provide a succinct answer. 7976.5. What is the ratio of the HFC emissions (in thousand metric tons of CO2 equivalent) in 2000 in Mexico to that in New Zealand?
Your response must be concise. 9.64. What is the ratio of the HFC emissions (in thousand metric tons of CO2 equivalent) in 2005 in Mexico to that in New Zealand?
Offer a very short reply. 9.78. What is the ratio of the HFC emissions (in thousand metric tons of CO2 equivalent) in 2008 in Mexico to that in New Zealand?
Your answer should be compact. 9.06. What is the ratio of the HFC emissions (in thousand metric tons of CO2 equivalent) in 1990 in Mexico to that in Poland?
Ensure brevity in your answer.  1.60e+04. What is the ratio of the HFC emissions (in thousand metric tons of CO2 equivalent) of 2000 in Mexico to that in Poland?
Provide a short and direct response. 5.02. What is the ratio of the HFC emissions (in thousand metric tons of CO2 equivalent) of 2005 in Mexico to that in Poland?
Provide a succinct answer. 4.06. What is the ratio of the HFC emissions (in thousand metric tons of CO2 equivalent) in 2008 in Mexico to that in Poland?
Your response must be concise. 3.7. What is the ratio of the HFC emissions (in thousand metric tons of CO2 equivalent) in 1990 in Mexico to that in Portugal?
Provide a succinct answer. 7976.5. What is the ratio of the HFC emissions (in thousand metric tons of CO2 equivalent) of 2000 in Mexico to that in Portugal?
Provide a succinct answer. 9.49. What is the ratio of the HFC emissions (in thousand metric tons of CO2 equivalent) of 2005 in Mexico to that in Portugal?
Ensure brevity in your answer.  10.9. What is the ratio of the HFC emissions (in thousand metric tons of CO2 equivalent) in 2008 in Mexico to that in Portugal?
Your response must be concise. 10.3. What is the ratio of the HFC emissions (in thousand metric tons of CO2 equivalent) of 1990 in Netherlands to that in New Zealand?
Offer a very short reply. 1.40e+04. What is the ratio of the HFC emissions (in thousand metric tons of CO2 equivalent) in 2000 in Netherlands to that in New Zealand?
Provide a short and direct response. 17.85. What is the ratio of the HFC emissions (in thousand metric tons of CO2 equivalent) of 2005 in Netherlands to that in New Zealand?
Make the answer very short. 4.32. What is the ratio of the HFC emissions (in thousand metric tons of CO2 equivalent) in 2008 in Netherlands to that in New Zealand?
Keep it short and to the point. 4.11. What is the ratio of the HFC emissions (in thousand metric tons of CO2 equivalent) of 1990 in Netherlands to that in Poland?
Provide a short and direct response. 2.79e+04. What is the ratio of the HFC emissions (in thousand metric tons of CO2 equivalent) in 2000 in Netherlands to that in Poland?
Your response must be concise. 9.29. What is the ratio of the HFC emissions (in thousand metric tons of CO2 equivalent) of 2005 in Netherlands to that in Poland?
Provide a short and direct response. 1.8. What is the ratio of the HFC emissions (in thousand metric tons of CO2 equivalent) of 2008 in Netherlands to that in Poland?
Your response must be concise. 1.68. What is the ratio of the HFC emissions (in thousand metric tons of CO2 equivalent) of 1990 in Netherlands to that in Portugal?
Your answer should be compact. 1.40e+04. What is the ratio of the HFC emissions (in thousand metric tons of CO2 equivalent) in 2000 in Netherlands to that in Portugal?
Ensure brevity in your answer.  17.58. What is the ratio of the HFC emissions (in thousand metric tons of CO2 equivalent) in 2005 in Netherlands to that in Portugal?
Your answer should be compact. 4.82. What is the ratio of the HFC emissions (in thousand metric tons of CO2 equivalent) in 2008 in Netherlands to that in Portugal?
Give a very brief answer. 4.67. What is the ratio of the HFC emissions (in thousand metric tons of CO2 equivalent) of 1990 in New Zealand to that in Poland?
Make the answer very short. 2. What is the ratio of the HFC emissions (in thousand metric tons of CO2 equivalent) of 2000 in New Zealand to that in Poland?
Offer a terse response. 0.52. What is the ratio of the HFC emissions (in thousand metric tons of CO2 equivalent) in 2005 in New Zealand to that in Poland?
Give a very brief answer. 0.42. What is the ratio of the HFC emissions (in thousand metric tons of CO2 equivalent) in 2008 in New Zealand to that in Poland?
Your answer should be very brief. 0.41. What is the ratio of the HFC emissions (in thousand metric tons of CO2 equivalent) in 2000 in New Zealand to that in Portugal?
Provide a succinct answer. 0.98. What is the ratio of the HFC emissions (in thousand metric tons of CO2 equivalent) of 2005 in New Zealand to that in Portugal?
Provide a short and direct response. 1.11. What is the ratio of the HFC emissions (in thousand metric tons of CO2 equivalent) of 2008 in New Zealand to that in Portugal?
Keep it short and to the point. 1.14. What is the ratio of the HFC emissions (in thousand metric tons of CO2 equivalent) of 1990 in Poland to that in Portugal?
Your answer should be very brief. 0.5. What is the ratio of the HFC emissions (in thousand metric tons of CO2 equivalent) of 2000 in Poland to that in Portugal?
Your answer should be very brief. 1.89. What is the ratio of the HFC emissions (in thousand metric tons of CO2 equivalent) in 2005 in Poland to that in Portugal?
Your answer should be very brief. 2.68. What is the ratio of the HFC emissions (in thousand metric tons of CO2 equivalent) in 2008 in Poland to that in Portugal?
Offer a terse response. 2.78. What is the difference between the highest and the second highest HFC emissions (in thousand metric tons of CO2 equivalent) of 1990?
Provide a short and direct response. 1197.6. What is the difference between the highest and the second highest HFC emissions (in thousand metric tons of CO2 equivalent) in 2000?
Offer a terse response. 2853.1. What is the difference between the highest and the second highest HFC emissions (in thousand metric tons of CO2 equivalent) in 2005?
Ensure brevity in your answer.  3939.4. What is the difference between the highest and the second highest HFC emissions (in thousand metric tons of CO2 equivalent) in 2008?
Make the answer very short. 4808.1. What is the difference between the highest and the lowest HFC emissions (in thousand metric tons of CO2 equivalent) in 1990?
Provide a short and direct response. 2792.8. What is the difference between the highest and the lowest HFC emissions (in thousand metric tons of CO2 equivalent) in 2000?
Provide a succinct answer. 6193.5. What is the difference between the highest and the lowest HFC emissions (in thousand metric tons of CO2 equivalent) in 2005?
Make the answer very short. 7032.8. What is the difference between the highest and the lowest HFC emissions (in thousand metric tons of CO2 equivalent) in 2008?
Your answer should be very brief. 8757.7. 